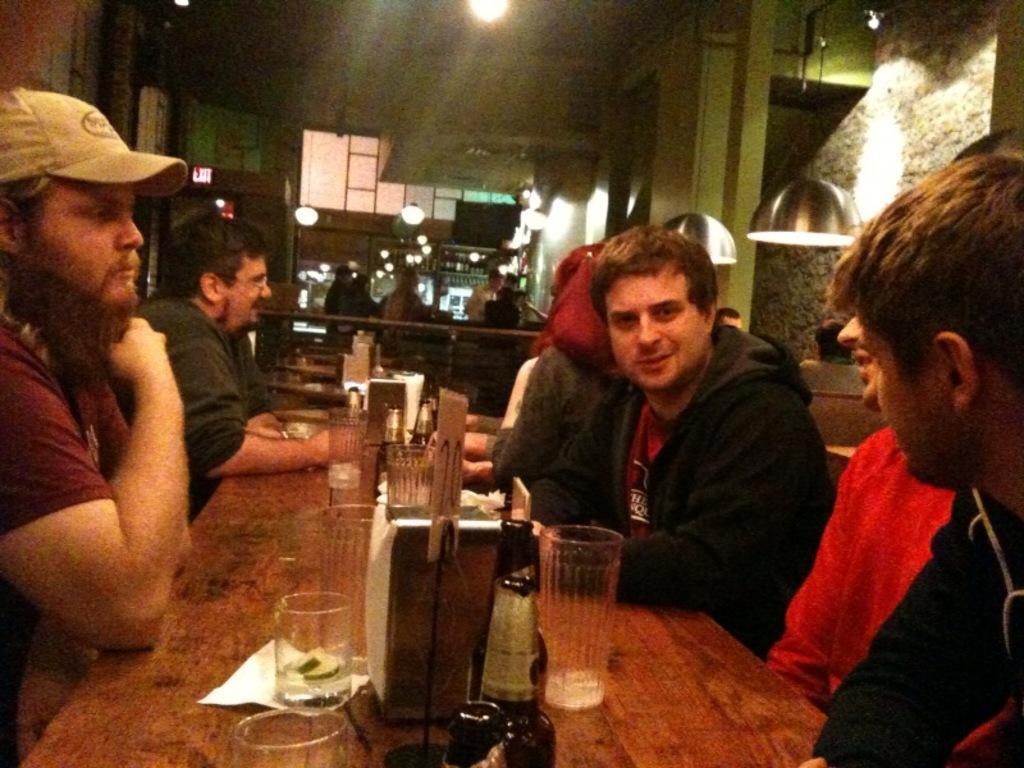Can you describe this image briefly? In this image I can see a table on the table I can see bottles, glasses and tissue paper ,at the top I can see lights and persons and the wall. 